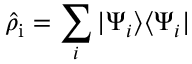<formula> <loc_0><loc_0><loc_500><loc_500>\hat { \rho } _ { i } = \sum _ { i } | \Psi _ { i } \rangle \langle \Psi _ { i } |</formula> 